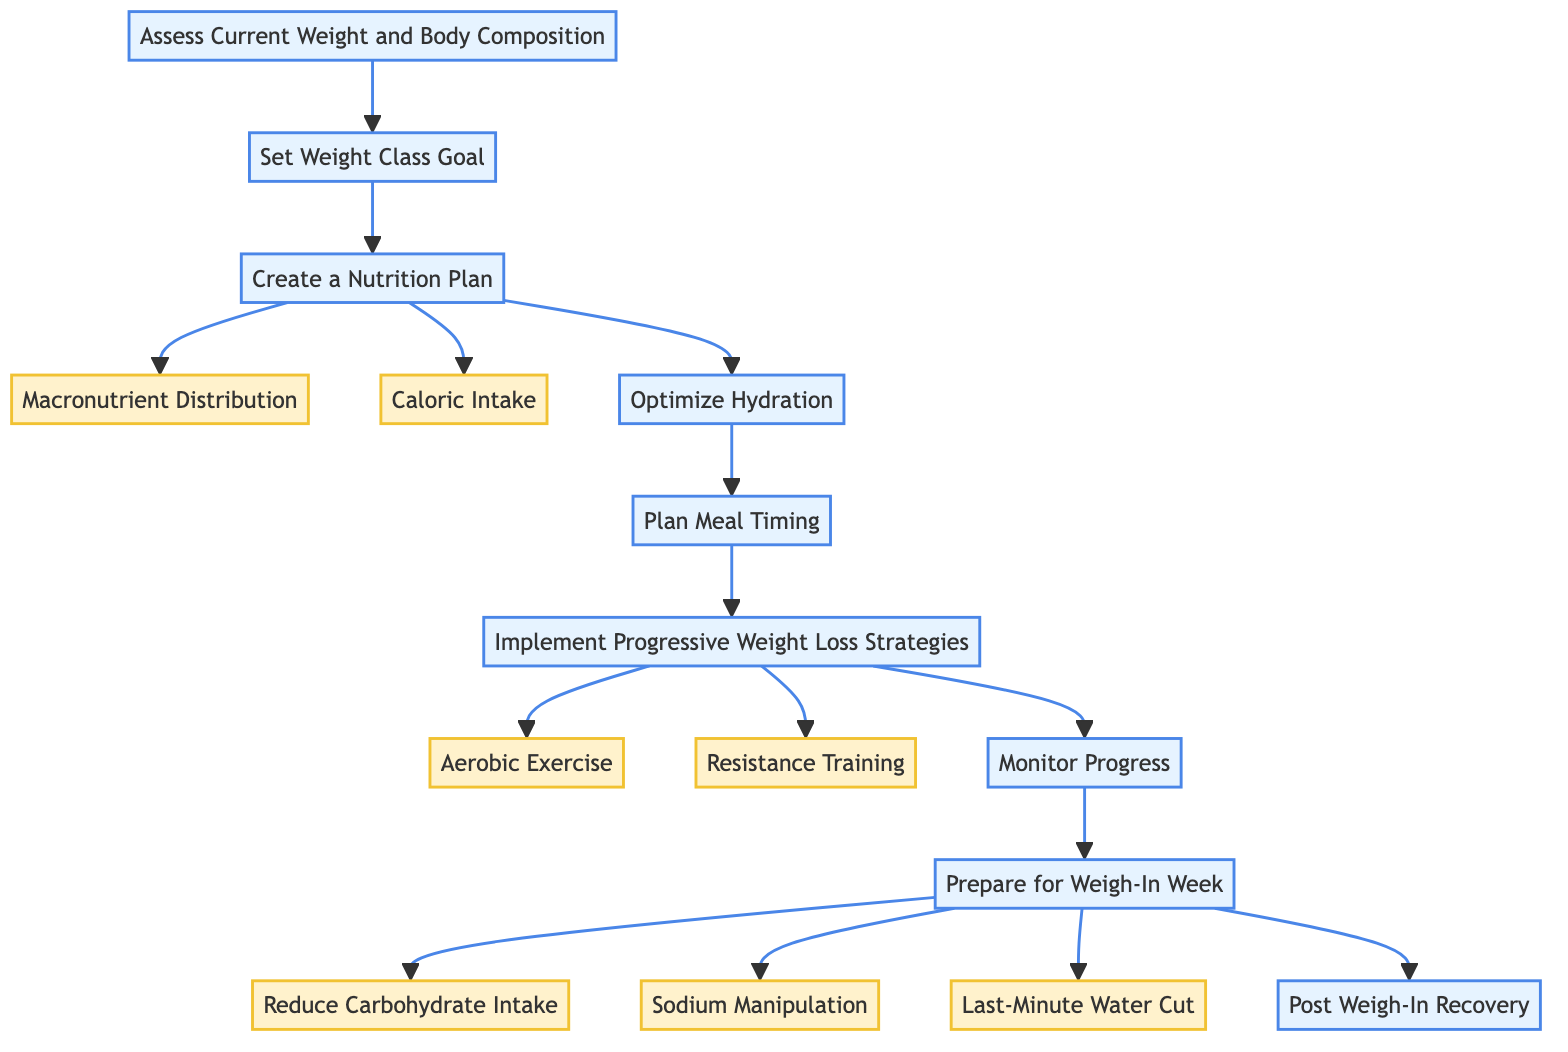What is the first step in the diet plan? The first step in the flowchart is "Assess Current Weight and Body Composition." It is identified as the starting point, connected directly to the next step.
Answer: Assess Current Weight and Body Composition How many steps are there in total? The diagram shows 8 main steps, each represented as a node connected sequentially. Counting each of the nodes confirms this total.
Answer: 8 Which two steps come directly after "Set Weight Class Goal"? After "Set Weight Class Goal," the flow leads to "Create a Nutrition Plan" and then "Optimize Hydration." These are the next two steps directly following it in the sequence.
Answer: Create a Nutrition Plan, Optimize Hydration What is the focus of the "Prepare for Weigh-In Week" step? This step includes three substeps which focus on reducing carbohydrate intake, sodium manipulation, and implementing a last-minute water cut, indicating a strategy to prepare for competition.
Answer: Reduce Carbohydrate Intake, Sodium Manipulation, Last-Minute Water Cut What are the two substeps involved in "Implement Progressive Weight Loss Strategies"? The substeps are "Aerobic Exercise" and "Resistance Training." Each of these is aimed at enhancing weight loss while preserving muscle mass.
Answer: Aerobic Exercise, Resistance Training Which step follows "Monitor Progress"? The step that follows "Monitor Progress" is "Prepare for Weigh-In Week," indicating that after monitoring, the focus shifts to preparations necessary for the weigh-in.
Answer: Prepare for Weigh-In Week How is "Optimize Hydration" connected to the other steps? "Optimize Hydration" occurs after "Create a Nutrition Plan" and before "Plan Meal Timing," showing a logical flow from nutrition planning to hydration strategy, emphasizing their interrelation in a weight-cutting diet.
Answer: After Create a Nutrition Plan, Before Plan Meal Timing What is the final step in the diagram? The final step in the flowchart is "Post Weigh-In Recovery," indicating the last phase of the diet plan after all previous steps have been implemented.
Answer: Post Weigh-In Recovery 